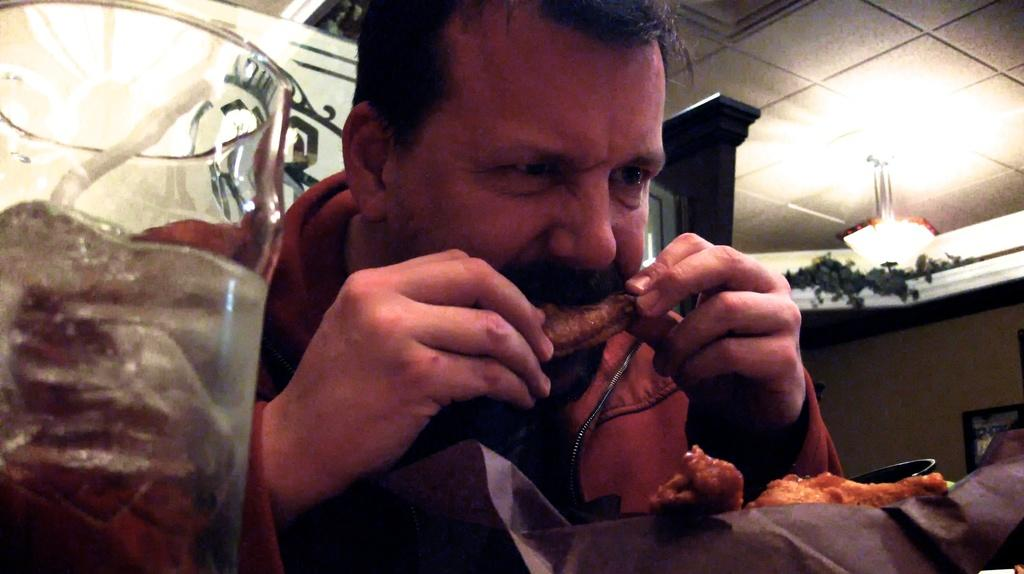Who is present in the image? There is a man in the image. What is the man doing in the image? The man is eating food in the image. What can be seen on the left side of the image? There is a glass on the left side of the image. What architectural feature is visible in the background of the image? There is a wall in the background of the image. What is above the man in the image? There is a ceiling in the image. What is hanging from the ceiling in the image? There is a chandelier at the top of the image. How many points does the jar have in the image? There is no jar present in the image, so it is not possible to determine how many points it might have. 